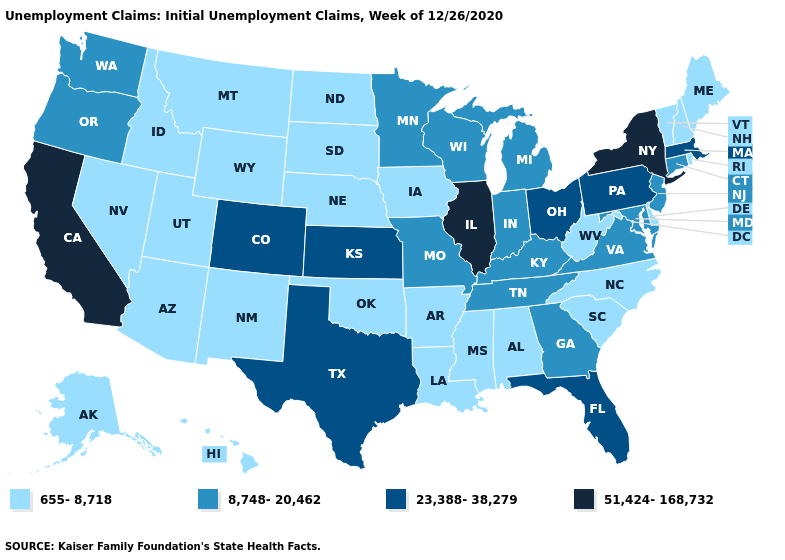Among the states that border West Virginia , does Pennsylvania have the highest value?
Answer briefly. Yes. What is the value of New Jersey?
Be succinct. 8,748-20,462. What is the value of Florida?
Answer briefly. 23,388-38,279. What is the value of Alabama?
Be succinct. 655-8,718. What is the value of Ohio?
Give a very brief answer. 23,388-38,279. Does Pennsylvania have the highest value in the Northeast?
Give a very brief answer. No. Among the states that border Kentucky , does Tennessee have the highest value?
Concise answer only. No. What is the lowest value in the South?
Give a very brief answer. 655-8,718. Which states have the highest value in the USA?
Concise answer only. California, Illinois, New York. Which states have the lowest value in the South?
Short answer required. Alabama, Arkansas, Delaware, Louisiana, Mississippi, North Carolina, Oklahoma, South Carolina, West Virginia. Does Kentucky have the lowest value in the South?
Concise answer only. No. Among the states that border Missouri , which have the highest value?
Give a very brief answer. Illinois. What is the value of Montana?
Short answer required. 655-8,718. What is the value of New Mexico?
Give a very brief answer. 655-8,718. 